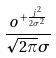<formula> <loc_0><loc_0><loc_500><loc_500>\frac { o ^ { + \frac { j ^ { 2 } } { 2 \sigma ^ { 2 } } } } { \sqrt { 2 \pi } \sigma }</formula> 